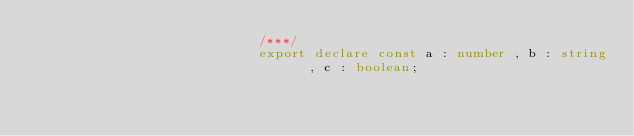Convert code to text. <code><loc_0><loc_0><loc_500><loc_500><_TypeScript_>                            /***/
                            export declare const a : number , b : string  , c : boolean;
                        </code> 